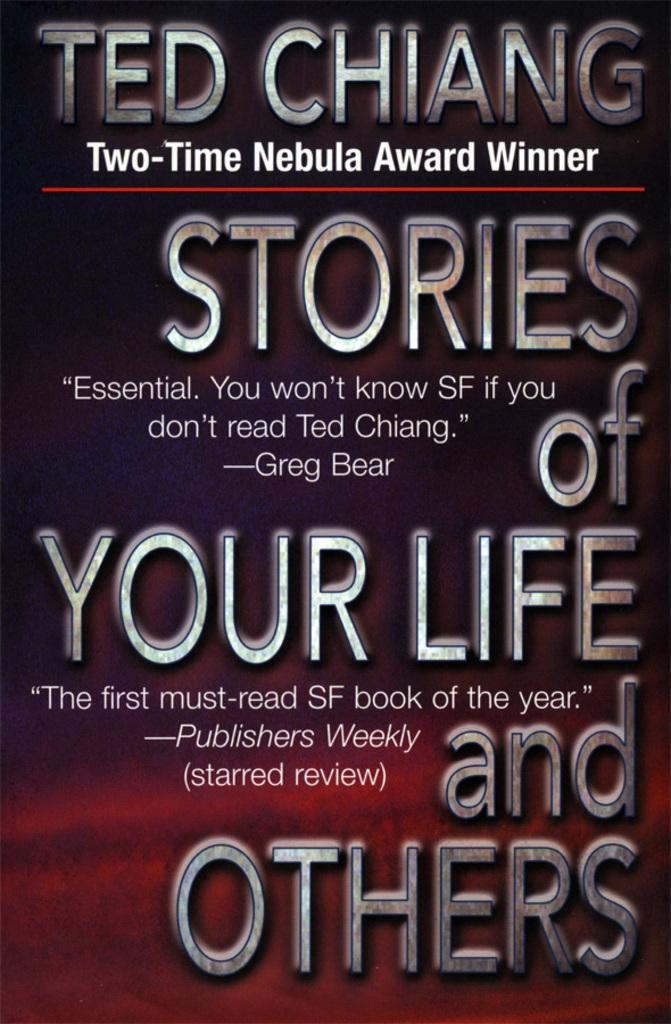<image>
Provide a brief description of the given image. A book cover displays the name Ted Chiang, who is the author. 